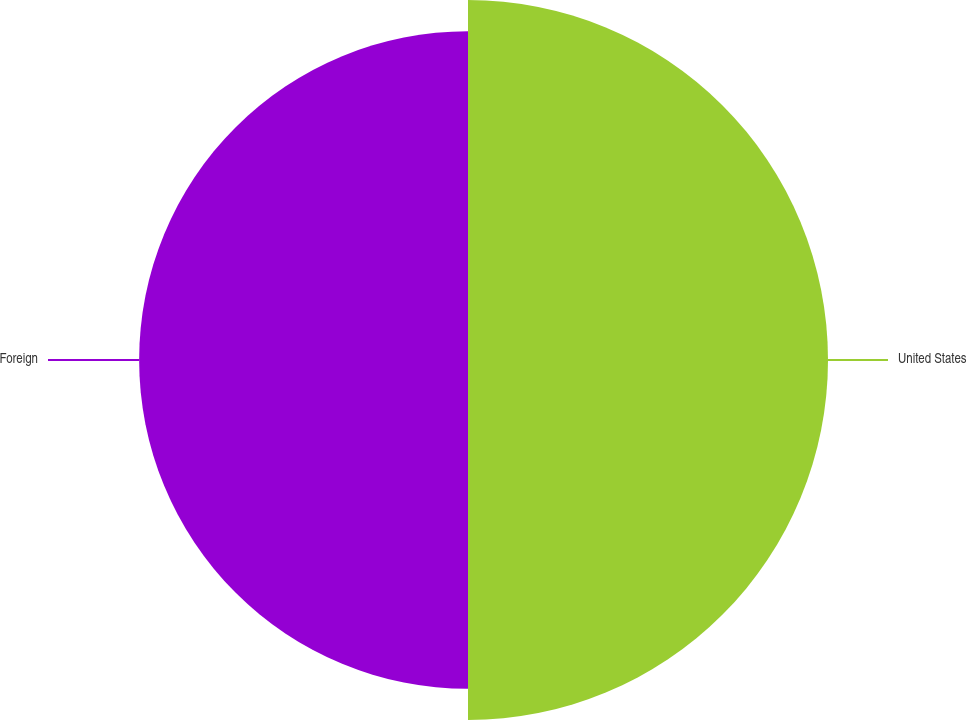Convert chart. <chart><loc_0><loc_0><loc_500><loc_500><pie_chart><fcel>United States<fcel>Foreign<nl><fcel>52.26%<fcel>47.74%<nl></chart> 